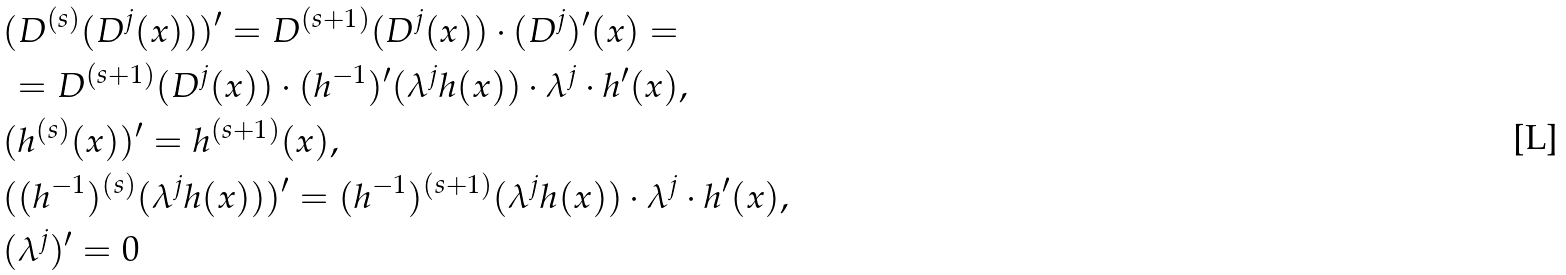Convert formula to latex. <formula><loc_0><loc_0><loc_500><loc_500>& ( D ^ { ( s ) } ( D ^ { j } ( x ) ) ) ^ { \prime } = D ^ { ( s + 1 ) } ( D ^ { j } ( x ) ) \cdot ( D ^ { j } ) ^ { \prime } ( x ) = \\ & \, = D ^ { ( s + 1 ) } ( D ^ { j } ( x ) ) \cdot ( h ^ { - 1 } ) ^ { \prime } ( \lambda ^ { j } h ( x ) ) \cdot \lambda ^ { j } \cdot h ^ { \prime } ( x ) , \\ & ( h ^ { ( s ) } ( x ) ) ^ { \prime } = h ^ { ( s + 1 ) } ( x ) , \\ & ( ( h ^ { - 1 } ) ^ { ( s ) } ( \lambda ^ { j } h ( x ) ) ) ^ { \prime } = ( h ^ { - 1 } ) ^ { ( s + 1 ) } ( \lambda ^ { j } h ( x ) ) \cdot \lambda ^ { j } \cdot h ^ { \prime } ( x ) , \\ & ( \lambda ^ { j } ) ^ { \prime } = 0</formula> 